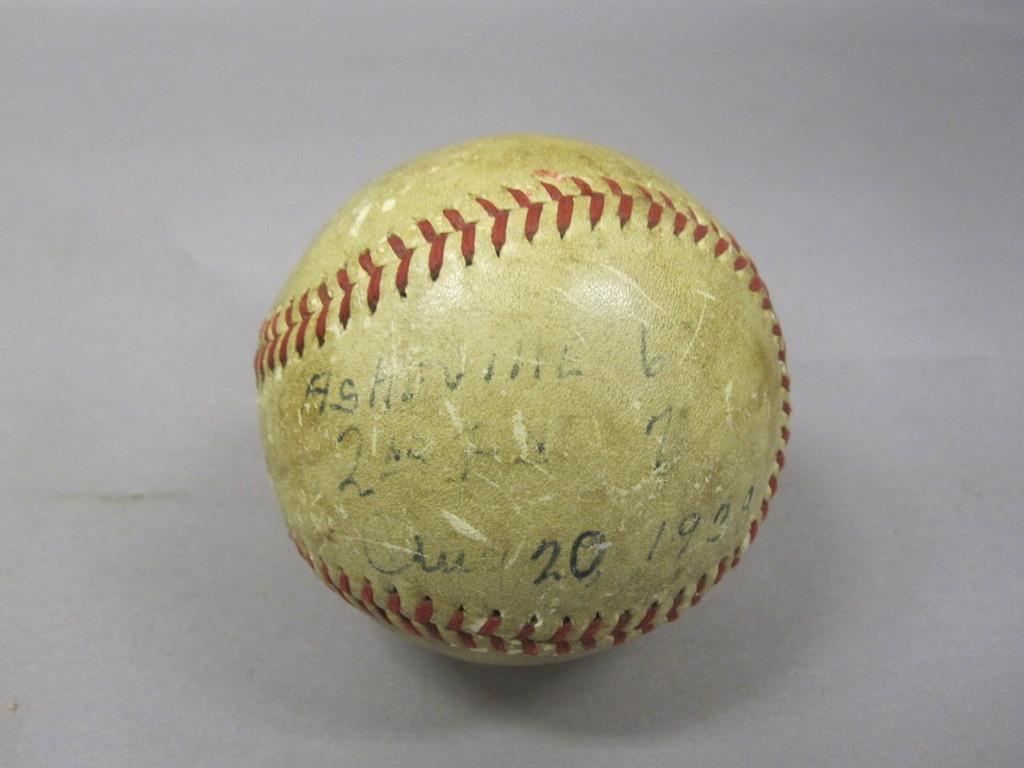What object is the main subject of the image? There is a ball in the image. Can you describe the appearance of the ball? The ball has designs on it and text on it. What is the color of the surface the ball is placed on? The ball is placed on a white surface. What type of feast is being prepared on the boat in the image? There is no boat or feast present in the image; it features a ball with designs and text on a white surface. Can you tell me which elbow is closest to the ball in the image? There are no elbows present in the image; it only features a ball on a white surface. 